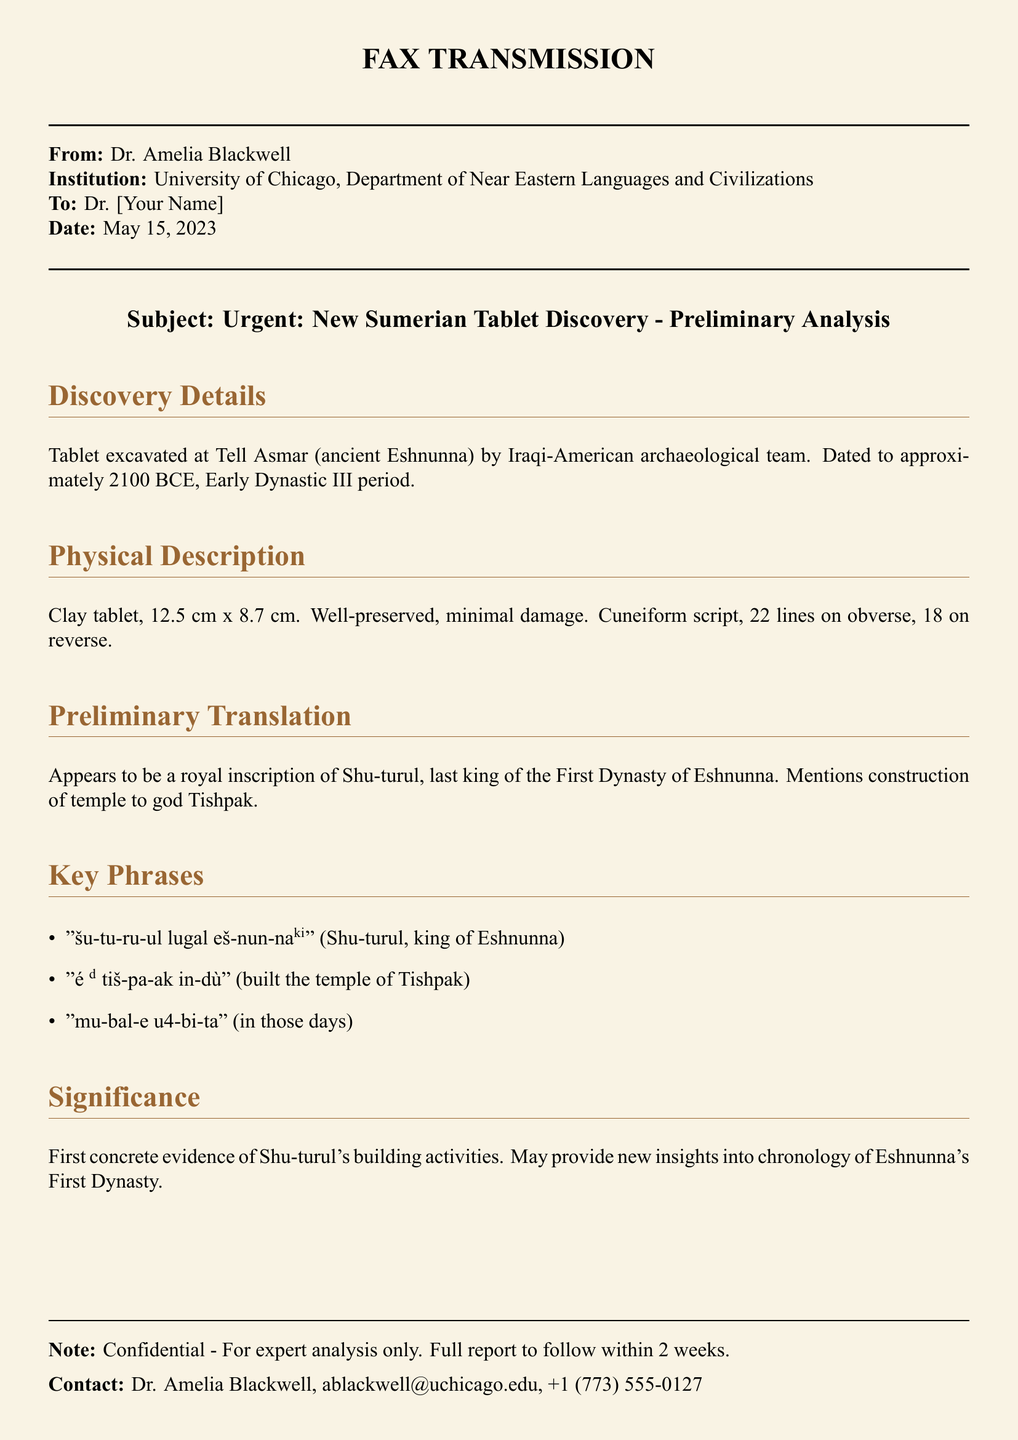What is the name of the institution sending the fax? The institution listed in the document is where Dr. Amelia Blackwell works, which is the University of Chicago, Department of Near Eastern Languages and Civilizations.
Answer: University of Chicago What is the date of the fax? The date is explicitly mentioned in the document.
Answer: May 15, 2023 What is the size of the clay tablet? The dimensions of the tablet are provided in the physical description section of the document.
Answer: 12.5 cm x 8.7 cm Who is the king mentioned in the preliminary translation? The preliminary translation identifies the royal figure associated with the tablet.
Answer: Shu-turul What period does the tablet date to? The document specifies the approximate dating of the tablet.
Answer: 2100 BCE What is the significance of the discovery mentioned? The significance is provided in a separate section of the document regarding its importance for historical understanding.
Answer: First concrete evidence of Shu-turul's building activities How many lines does the obverse of the tablet have? The document includes a physical description of the tablet detailing the number of lines.
Answer: 22 lines What is the subject of the fax? The subject line of the fax outlines the primary focus of the correspondence.
Answer: New Sumerian Tablet Discovery - Preliminary Analysis Who is the contact person for further inquiries? The document lists a specific individual for follow-up regarding the fax.
Answer: Dr. Amelia Blackwell 